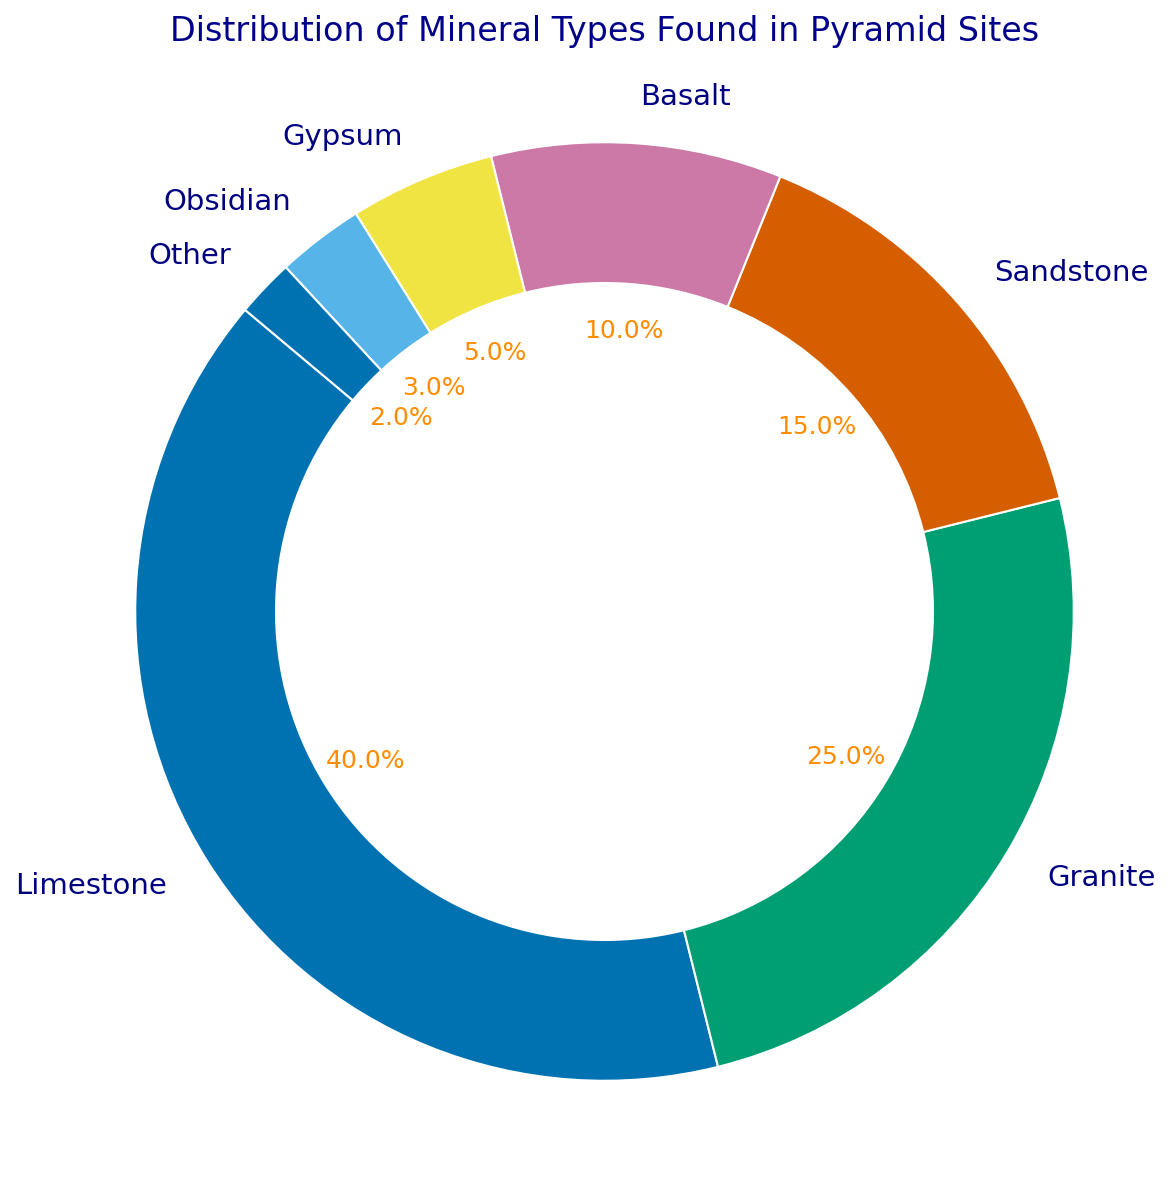What is the most abundant mineral type found in pyramid sites according to the chart? The chart shows the percentage distribution of mineral types. By looking at the segments, "Limestone" has the largest percentage.
Answer: Limestone Which two mineral types together make up more than 50% of the distribution? From the chart, "Limestone" is 40% and "Granite" is 25%. Adding these percentages, 40% + 25% = 65%, which is more than 50%.
Answer: Limestone and Granite What percentage of the total does Basalt and Gypsum together contribute? According to the chart, Basalt is 10% and Gypsum is 5%. Adding these percentages, 10% + 5% = 15%.
Answer: 15% Is Obsidian more prevalent than Gypsum in the distribution? From the chart, the percentage for Obsidian is 3% and for Gypsum, it is 5%. Since 3% is less than 5%, Obsidian is not more prevalent than Gypsum.
Answer: No Compare the prevalence of Sandstone to that of Basalt. Which one is more prevalent and by how much? According to the chart, Sandstone is 15% and Basalt is 10%. Therefore, Sandstone is more prevalent. Subtracting these percentages, 15% - 10% = 5%.
Answer: Sandstone is more prevalent by 5% How many types of minerals make up less than 10% each? From the chart, the mineral types with less than 10% each are Basalt (10%), Gypsum (5%), Obsidian (3%), and Other (2%). There are four such types.
Answer: 4 types What is the combined percentage of Granite, Sandstone, and Other in the distribution? According to the chart, Granite is 25%, Sandstone is 15%, and Other is 2%. Adding these percentages, 25% + 15% + 2% = 42%.
Answer: 42% Which mineral type has the smallest representation in the distribution and what is its percentage? From the chart, "Other" has the smallest segment with a percentage of 2%.
Answer: Other, 2% If you were to combine the percentages of all mineral types except Limestone and Granite, what would the total be? According to the chart, the percentages of minerals except Limestone (40%) and Granite (25%) are Sandstone (15%), Basalt (10%), Gypsum (5%), Obsidian (3%), and Other (2%). Adding these, 15% + 10% + 5% + 3% + 2% = 35%.
Answer: 35% What is the second least abundant mineral type and what is its percentage? From the chart, the second least abundant mineral type is Obsidian with a percentage of 3%, the least abundant being Other with 2%.
Answer: Obsidian (3%) 